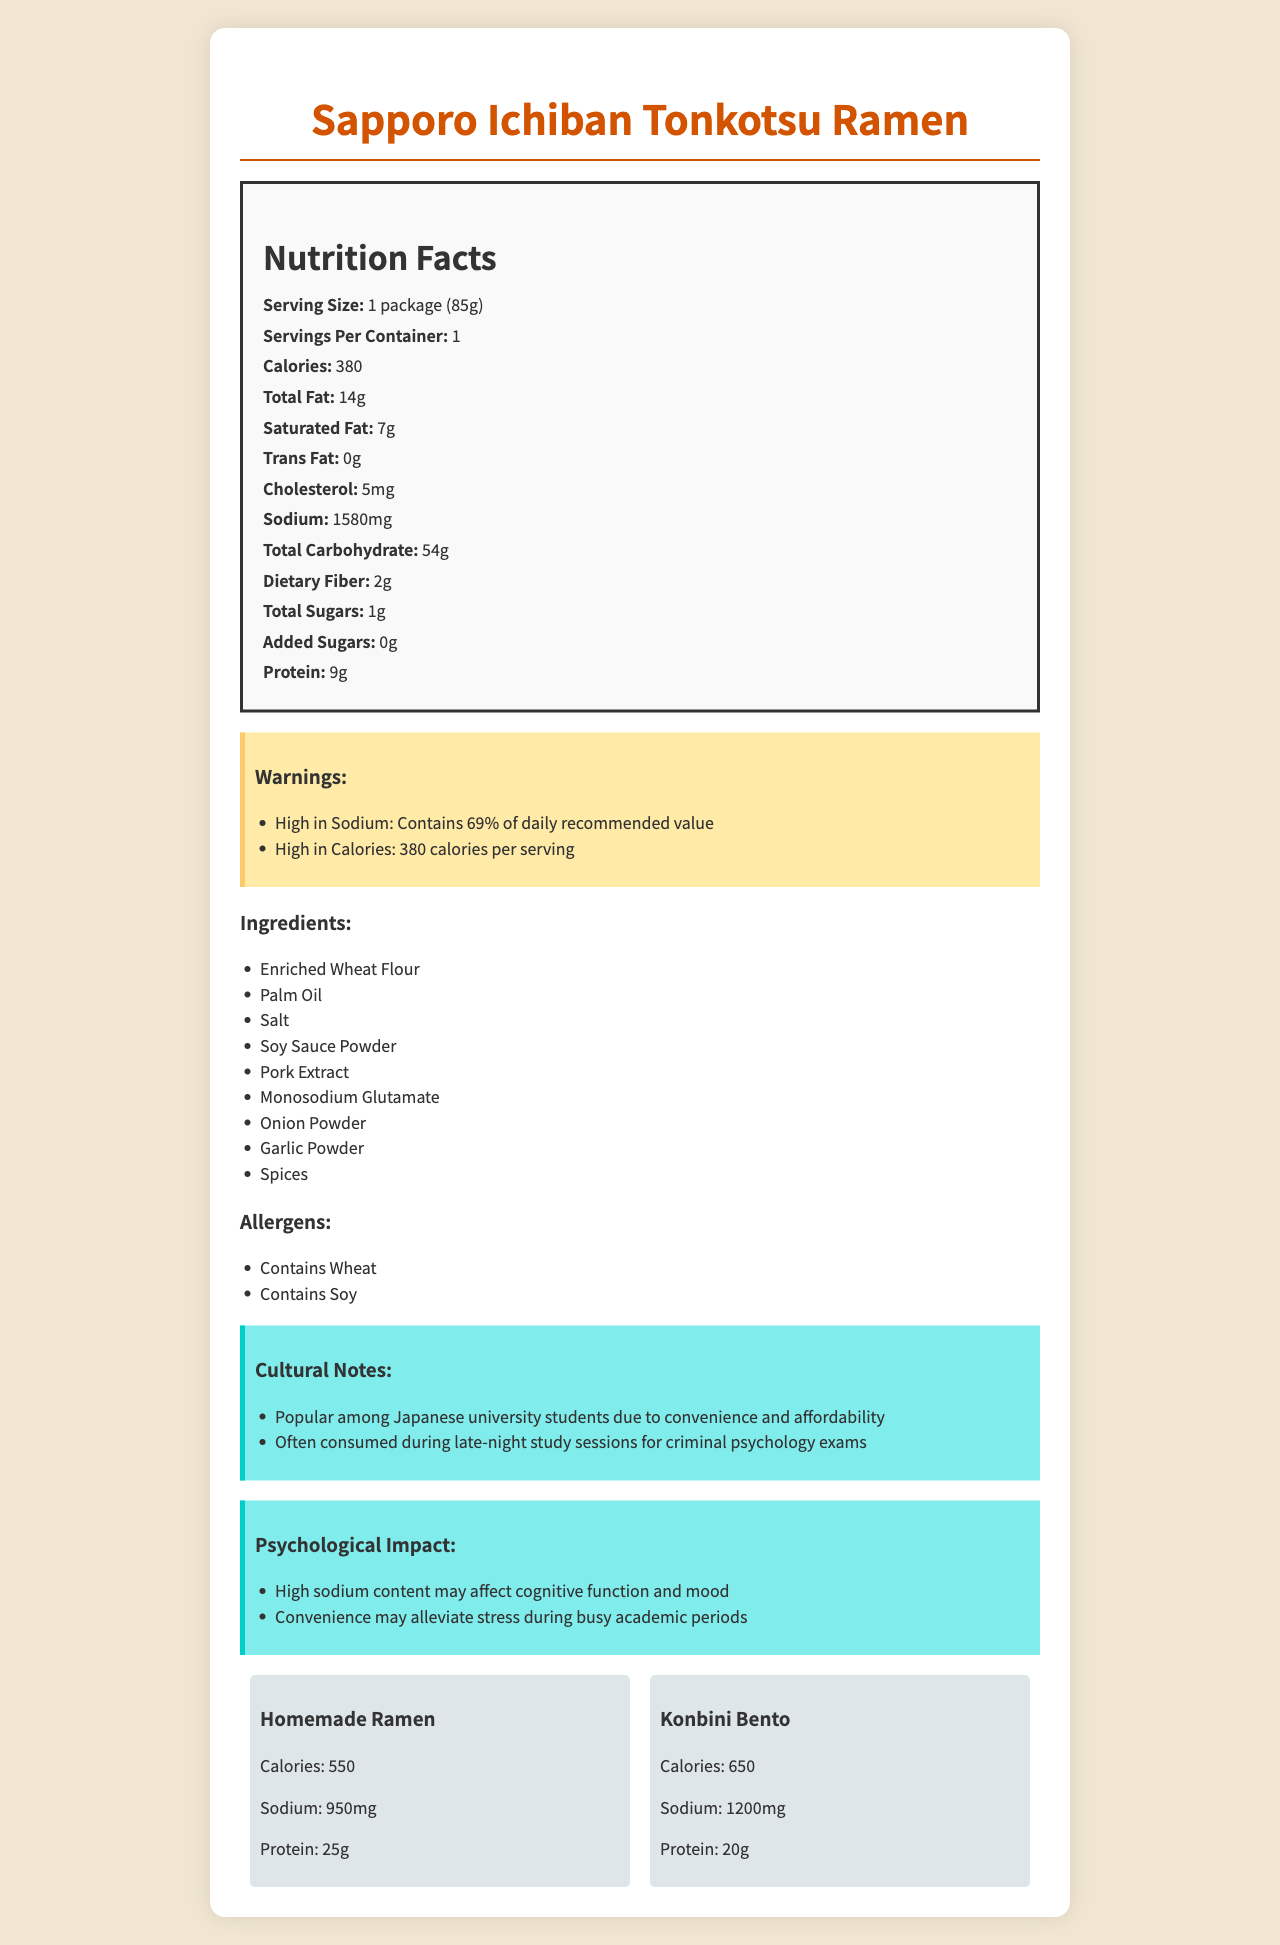what is the serving size? The serving size is listed in the Nutrition Facts section under "Serving Size."
Answer: 1 package (85g) How many calories are in one serving? The number of calories per serving is listed as "Calories" in the Nutrition Facts section.
Answer: 380 How much sodium does one serving contain? The amount of sodium per serving is listed under "Sodium" in the Nutrition Facts section.
Answer: 1580 mg Which ingredients in Sapporo Ichiban Tonkotsu Ramen contain allergens? The allergens are listed in a separate section under "Allergens," which include wheat and soy.
Answer: Enriched Wheat Flour and Soy Sauce Powder What is the total carbohydrate content per serving? The total carbohydrate content is listed under "Total Carbohydrate" in the Nutrition Facts section.
Answer: 54 g What is the protein content in a package of this ramen? The protein content is listed under "Protein" in the Nutrition Facts section.
Answer: 9 g What are the warnings associated with this product? A. Contains Dairy, High in Sugar B. High in Sodium, Contains Nuts C. High in Sodium, High in Calories The Warnings section lists "High in Sodium" and "High in Calories."
Answer: C Which nutrient has the highest percentage daily value warning in this product? A. Calcium B. Sodium C. Protein The warning section states that the sodium content is 69% of the daily recommended value.
Answer: B Is Sapporo Ichiban Tonkotsu Ramen low in saturated fat? The saturated fat content is 7g, which is relatively high.
Answer: No Summarize the key points of this nutrition label document. The answer summarizes the product’s nutrient content, warnings, ingredients, allergens, cultural context, psychological impact, and nutritional comparisons.
Answer: The document highlights the nutrition facts for "Sapporo Ichiban Tonkotsu Ramen," showing one package serving size with 380 calories, 14g total fat, 1580mg sodium, and 54g total carbohydrate. It warns about high sodium and calorie content and lists ingredients, allergens, cultural notes, and psychological impact. The product is popular among Japanese university students. Comparisons to homemade ramen and konbini bento are also provided. Does this product contain any added sugars? The "Added Sugars" value is 0g, as listed in the Nutrition Facts section.
Answer: No How popular is this product among university students in Japan? The Cultural Notes section mentions that it is popular among Japanese university students due to convenience and affordability.
Answer: Popular among Japanese university students Compare the sodium content in Sapporo Ichiban Tonkotsu Ramen to homemade ramen and konbini bento. The comparison shows that Sapporo Ichiban Tonkotsu Ramen has higher sodium content compared to both homemade ramen and konbini bento, as detailed in the comparison section.
Answer: Sapporo Ichiban Tonkotsu Ramen: 1580mg, Homemade Ramen: 950mg, Konbini Bento: 1200mg Can we determine the exact expiration date of this product from the document? The document does not provide any information about the expiration date.
Answer: Cannot be determined 